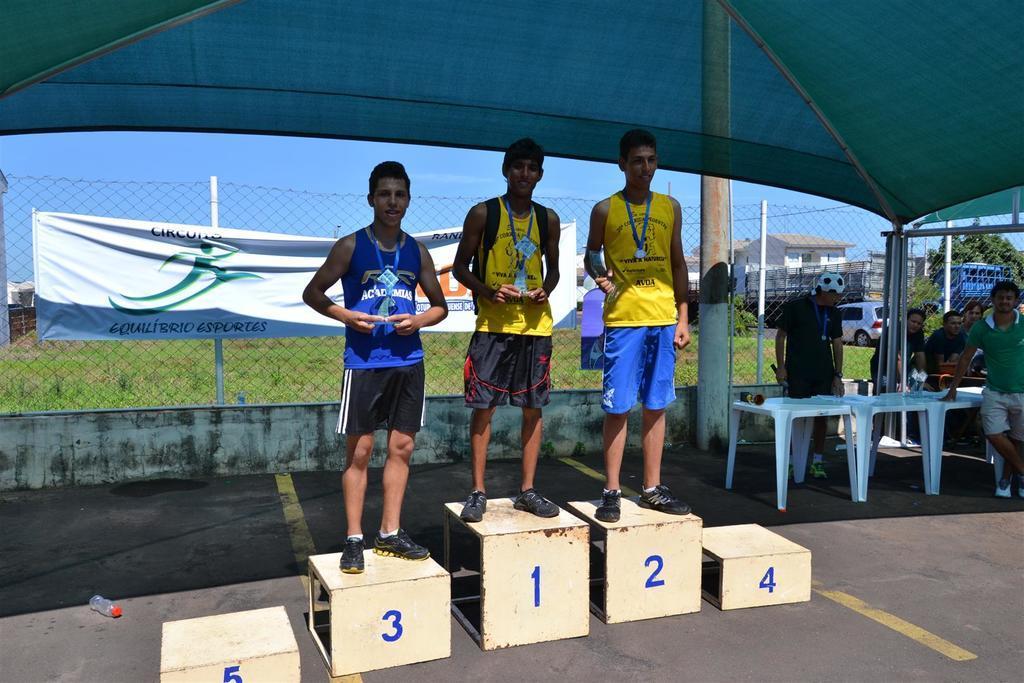Describe this image in one or two sentences. In this image there are three people are standing on the metal objects having numbers painted on it. They are holding the shields. Right side there are people standing on the floor. There is a banner attached to the fence. Right side there is a vehicle on the road. There are trees and buildings. Background there is sky. Top of the image there is a tent. 